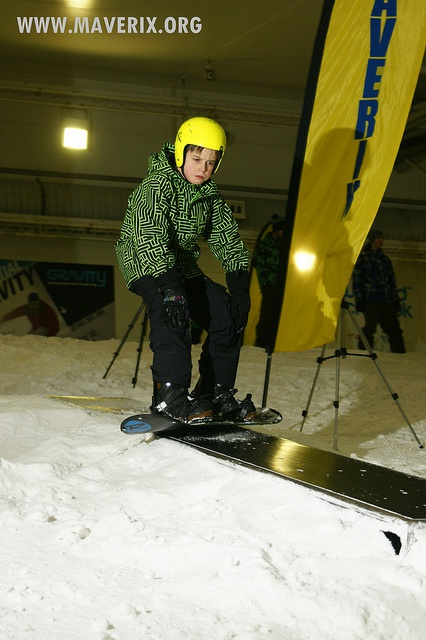Describe the objects in this image and their specific colors. I can see people in darkgreen, black, and yellow tones, snowboard in darkgreen, black, olive, gray, and khaki tones, people in darkgreen, black, olive, and gold tones, people in black, olive, and darkgreen tones, and snowboard in darkgreen, black, and gray tones in this image. 